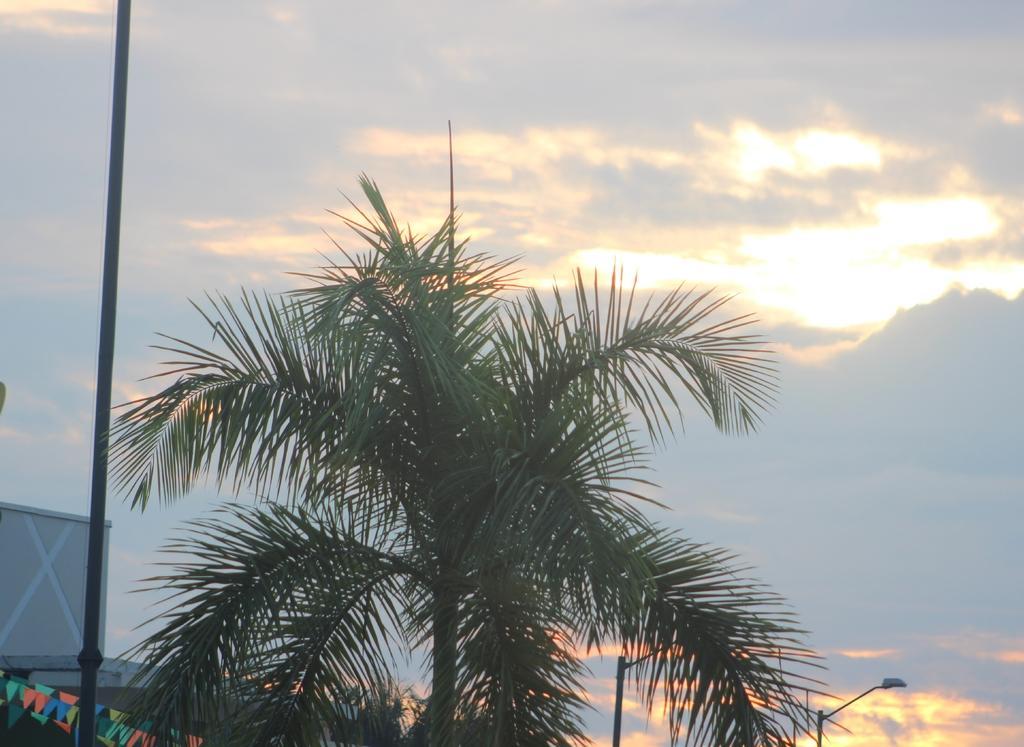Can you describe this image briefly? In the center of the image we can see a tree, electric light poles, flags, wall are present. At the top of the image clouds are present in the sky. 